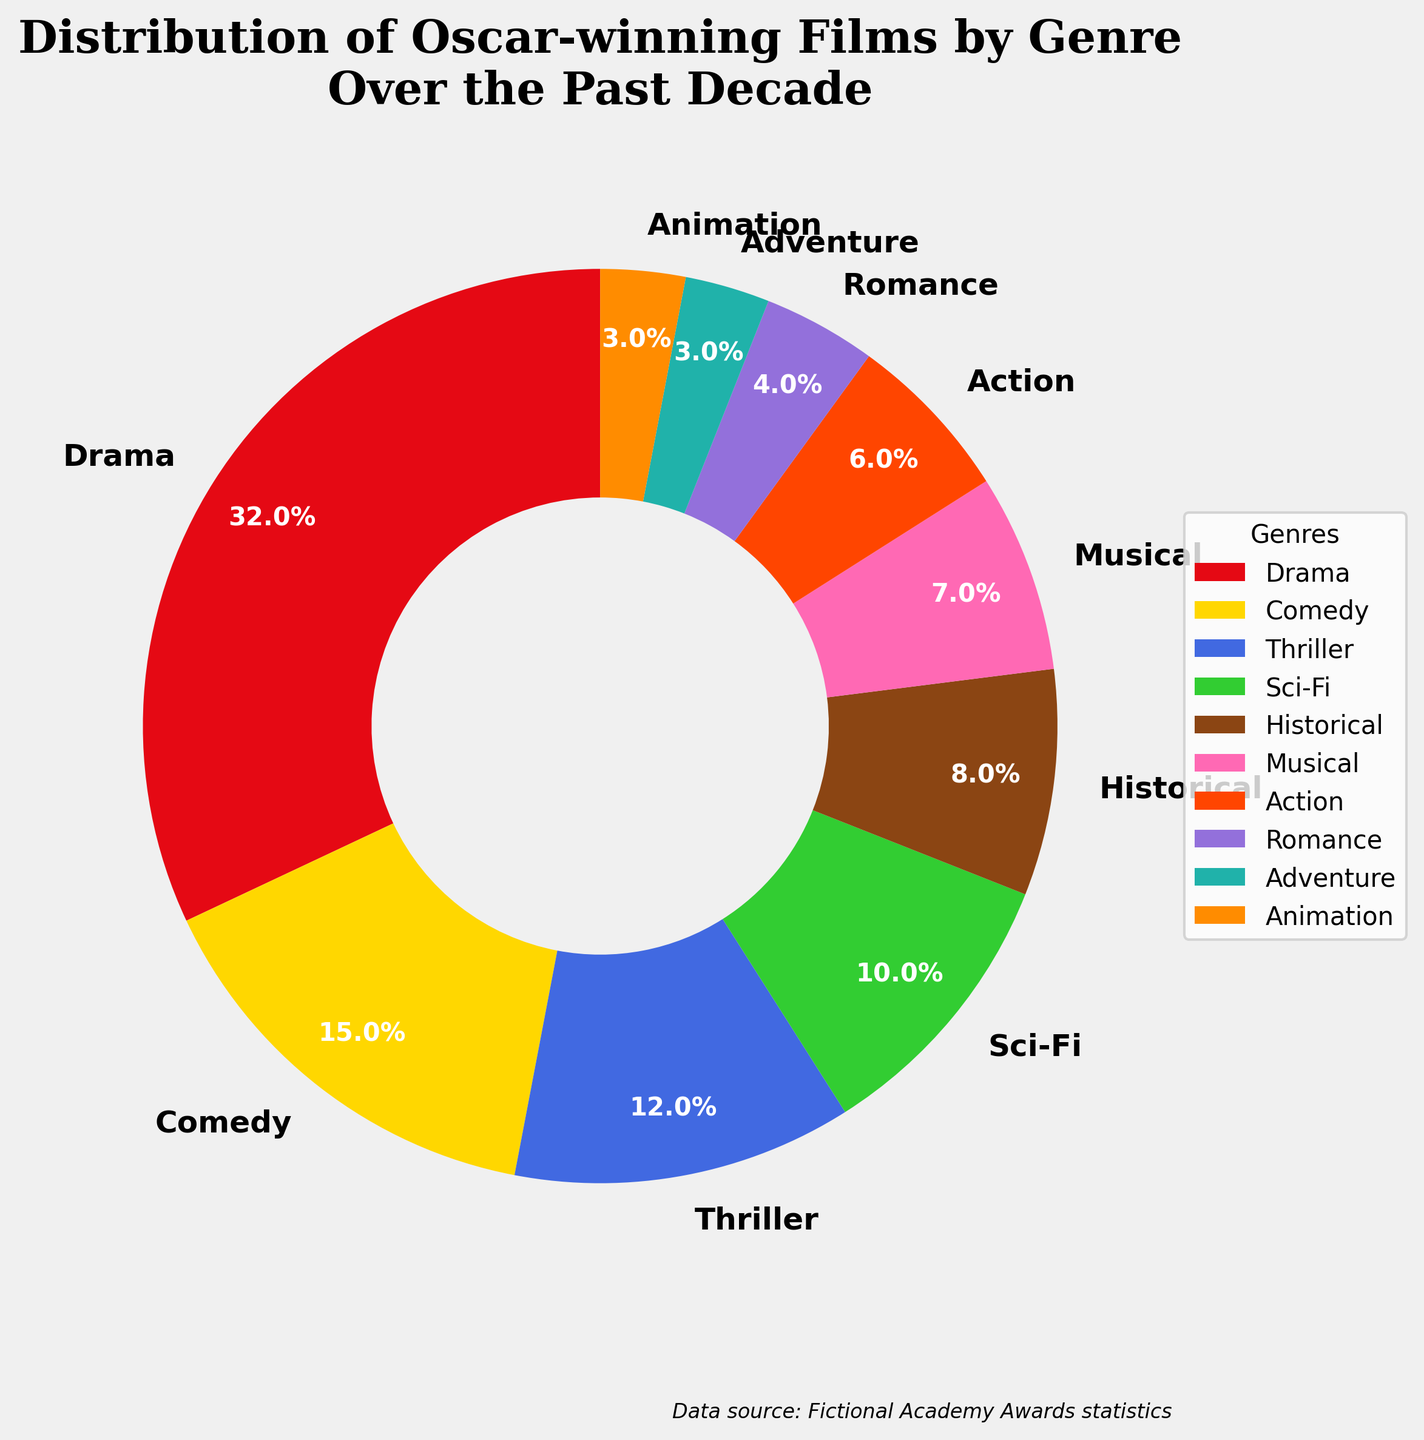What genre has the highest percentage of Oscar-winning films over the past decade? The pie chart shows the distribution of Oscar-winning films by genre, and the largest slice represents Drama.
Answer: Drama Which two genres combined make up a quarter (25%) of the Oscar-winning films? From the pie chart, Comedy (15%) and Thriller (12%) together total 27%.
Answer: Comedy and Thriller Which genre has twice the percentage of Adventure films? Adventure has 3%, so the genre with twice that would be 6%, which corresponds to Action.
Answer: Action Do Sci-Fi and Historical genres combined have a larger percentage than Drama alone? Sci-Fi (10%) + Historical (8%) = 18%, which is less than Drama's 32%.
Answer: No Which genres have a smaller percentage than Musical films? Musical has 7%, and Adventure (3%), Animation (3%), and Romance (4%) all have smaller percentages.
Answer: Adventure, Animation, and Romance What is the total percentage of the top three genres? Drama (32%) + Comedy (15%) + Thriller (12%) = 59%.
Answer: 59% If Musicals and Romances are combined, will their total be larger than the Sci-Fi genre alone? Musicals (7%) + Romance (4%) = 11%, which is just above Sci-Fi's 10%.
Answer: Yes Which genre is directly less than Sci-Fi in percentage? Sci-Fi has 10%, and directly less is Historical with 8%.
Answer: Historical What percentage of Oscar-winning films are in the combined categories of Historical, Action, and Romance? Historical (8%) + Action (6%) + Romance (4%) = 18%.
Answer: 18% Which genre has a percentage closest to Sci-Fi but not equal to it? Musical is the closest to Sci-Fi (10%) with 7%.
Answer: Musical 